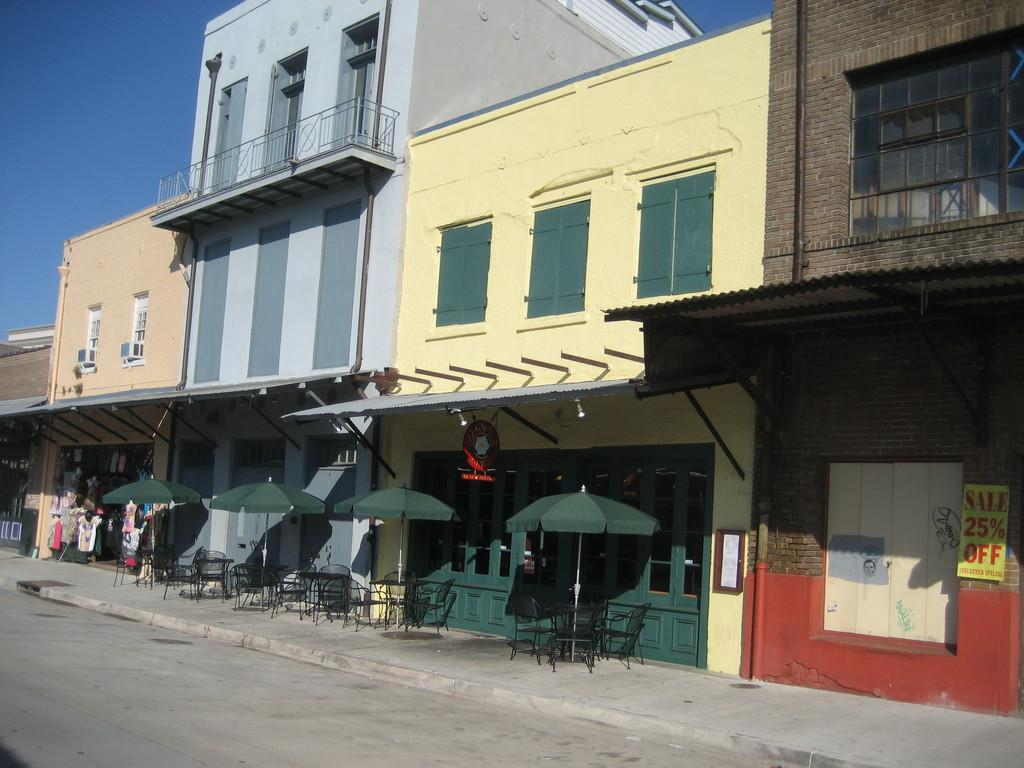What type of structures can be seen in the image? There are many buildings in the image. What objects are present for protection from the sun or rain? There are umbrellas in the image. What type of seating is available in the image? There are chairs in the image. What type of pathway is visible in the image? It is a footpath in the image. What type of barrier is present in the image? There is a fence in the image. What part of the natural environment is visible in the image? The sky is visible in the image. What type of business can be seen in the image? There is a cloth shop in the image. What type of signage is present in the image? There is a poster in the image. What type of opening is present in one of the buildings? There is a window in the image. What type of curtain is hanging in the window in the image? There is no curtain visible in the window in the image. What type of class is being taught in the image? There is no class or teaching activity depicted in the image. What type of tramp is jumping over the fence in the image? There is no tramp or jumping activity depicted in the image. 